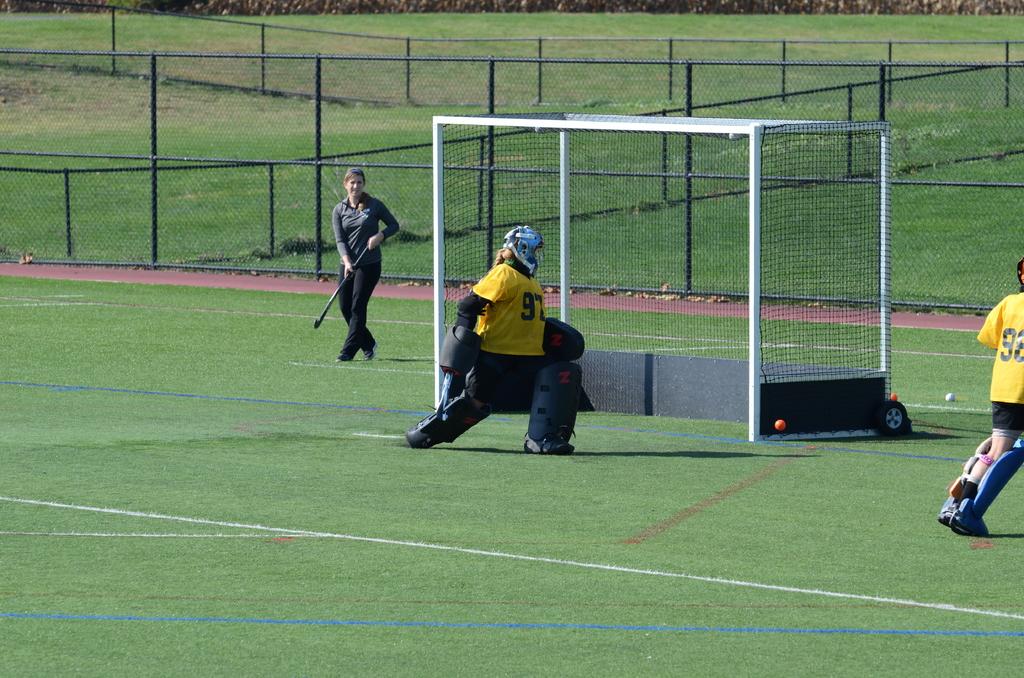What player number is the goalie?
Your answer should be compact. 97. What number is the girl on the far right?
Your response must be concise. 92. 